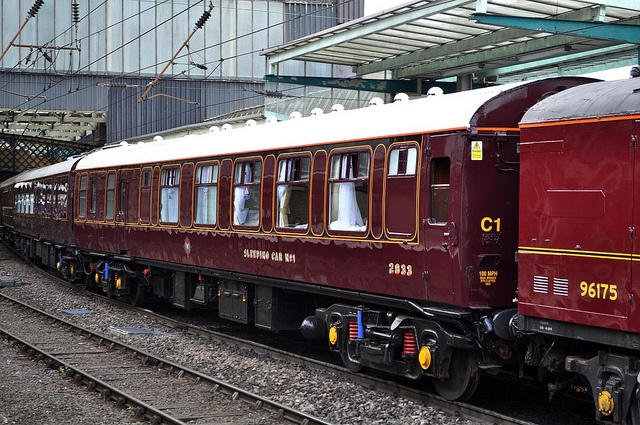Describe the objects in this image and their specific colors. I can see a train in darkgray, black, maroon, white, and gray tones in this image. 